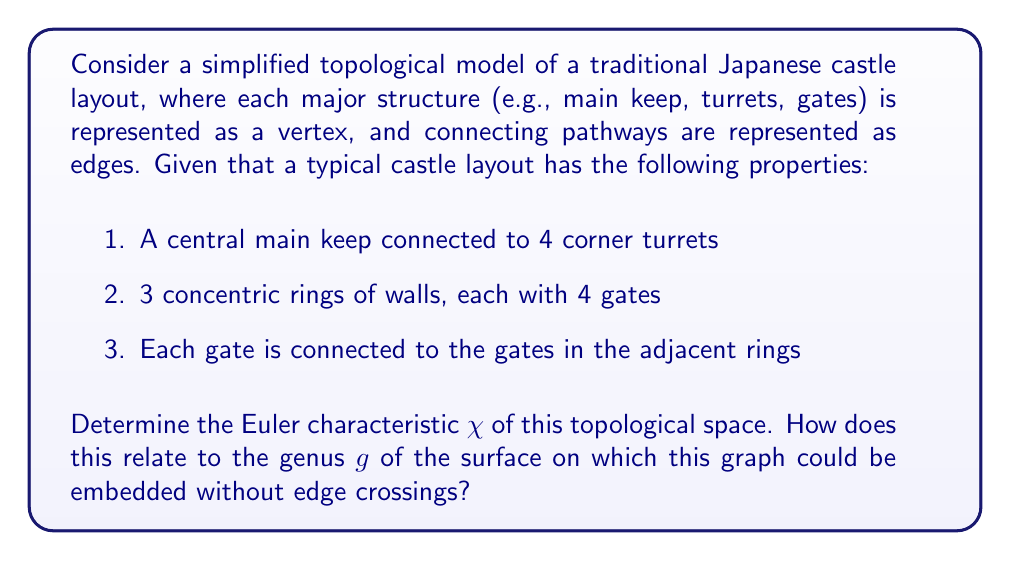Can you answer this question? To solve this problem, we'll follow these steps:

1. Count the number of vertices (V):
   - 1 main keep
   - 4 corner turrets
   - 12 gates (4 gates × 3 rings)
   Total vertices: V = 1 + 4 + 12 = 17

2. Count the number of edges (E):
   - 4 edges connecting main keep to corner turrets
   - 12 edges connecting gates in adjacent rings
   - 4 edges connecting outermost gates to corner turrets
   Total edges: E = 4 + 12 + 4 = 20

3. Count the number of faces (F):
   - 1 central area
   - 3 rings
   - 1 outer area
   Total faces: F = 1 + 3 + 1 = 5

4. Calculate the Euler characteristic:
   $$\chi = V - E + F = 17 - 20 + 5 = 2$$

5. Relate Euler characteristic to genus:
   For a closed orientable surface, the Euler characteristic and genus are related by the formula:
   $$\chi = 2 - 2g$$

   Solving for g:
   $$2 = 2 - 2g$$
   $$2g = 0$$
   $$g = 0$$

This result indicates that the graph can be embedded on a surface with genus 0, which is topologically equivalent to a sphere.
Answer: The Euler characteristic $\chi$ of the simplified Japanese castle layout is 2. This corresponds to a genus $g = 0$, indicating that the graph can be embedded on a sphere without edge crossings. 